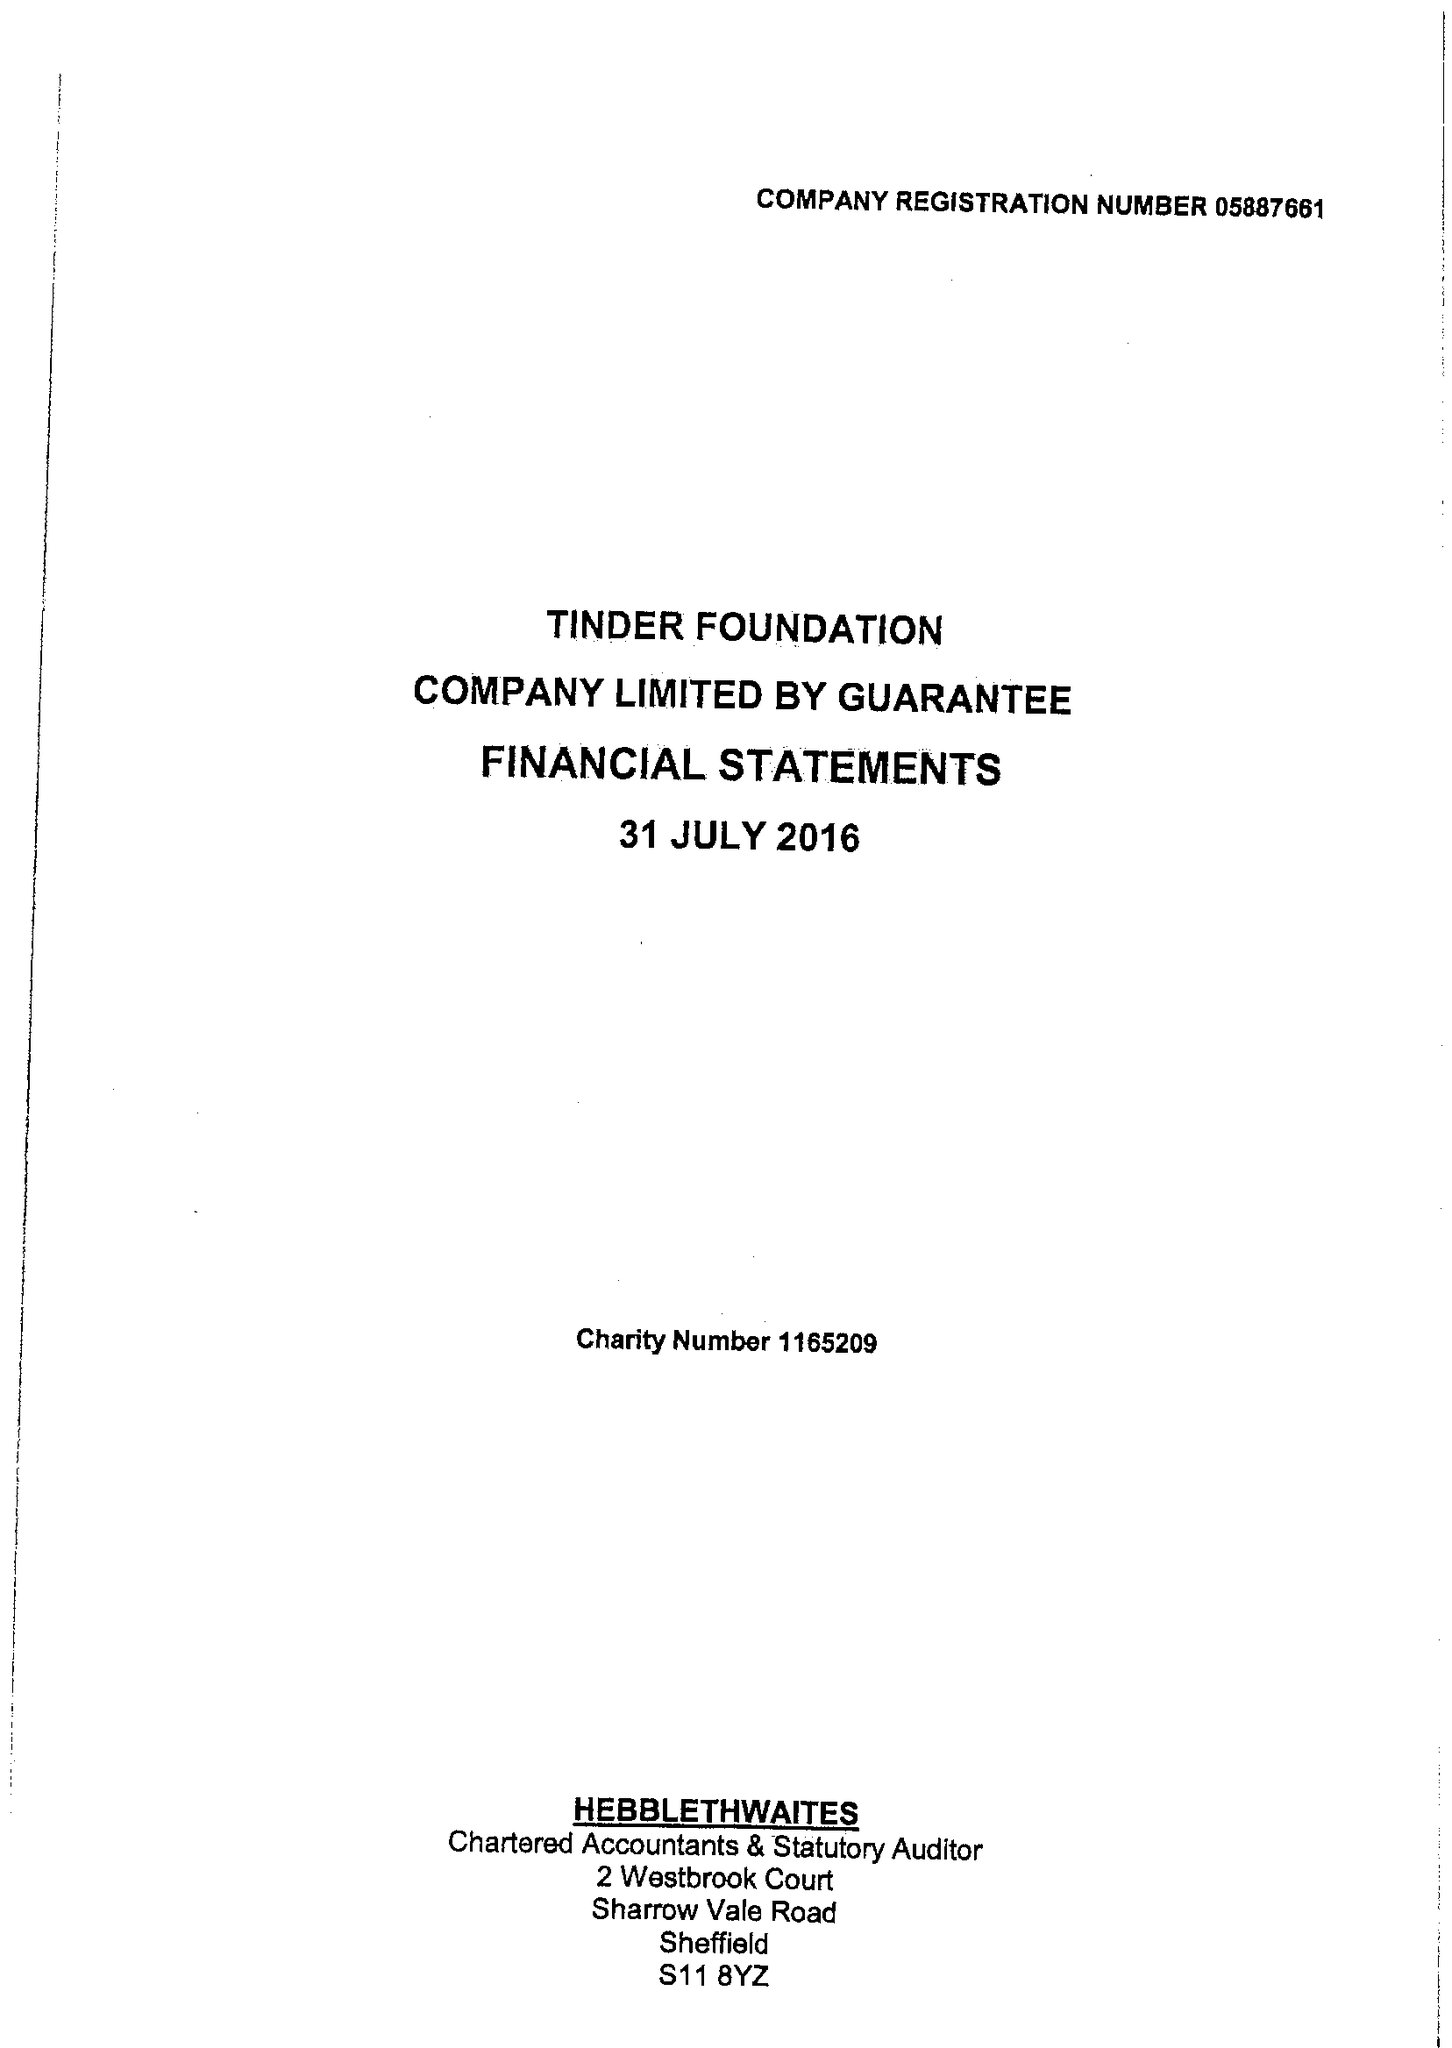What is the value for the charity_number?
Answer the question using a single word or phrase. 1165209 